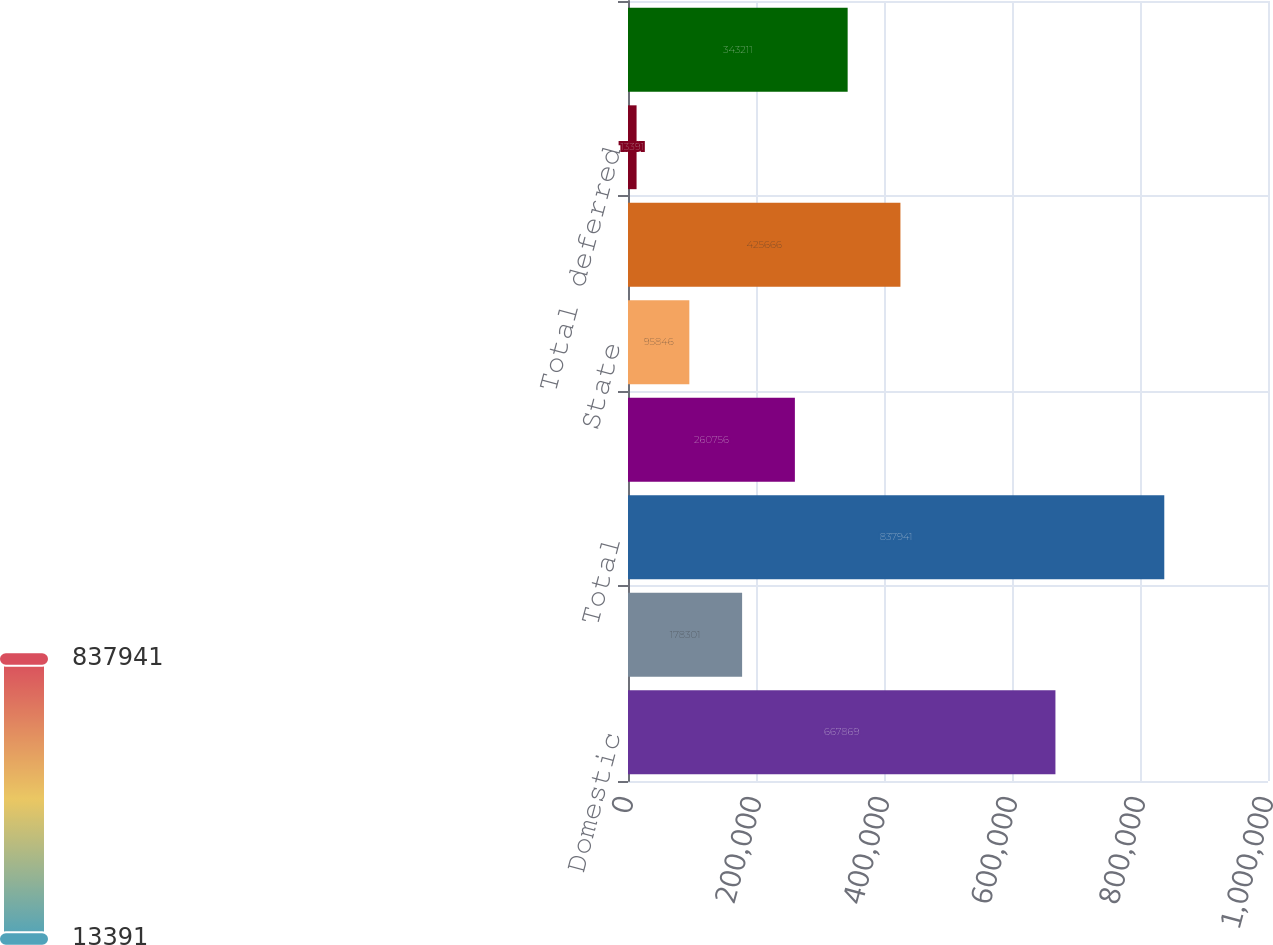Convert chart. <chart><loc_0><loc_0><loc_500><loc_500><bar_chart><fcel>Domestic<fcel>Foreign<fcel>Total<fcel>Federal<fcel>State<fcel>Total current<fcel>Total deferred<fcel>Total provision for income<nl><fcel>667869<fcel>178301<fcel>837941<fcel>260756<fcel>95846<fcel>425666<fcel>13391<fcel>343211<nl></chart> 